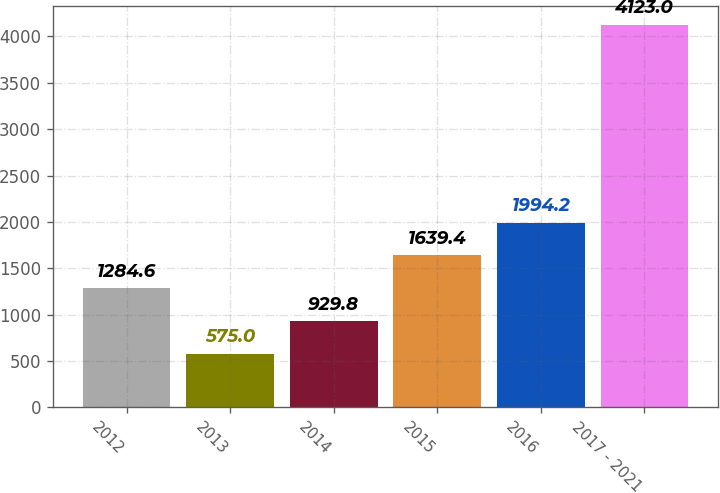<chart> <loc_0><loc_0><loc_500><loc_500><bar_chart><fcel>2012<fcel>2013<fcel>2014<fcel>2015<fcel>2016<fcel>2017 - 2021<nl><fcel>1284.6<fcel>575<fcel>929.8<fcel>1639.4<fcel>1994.2<fcel>4123<nl></chart> 